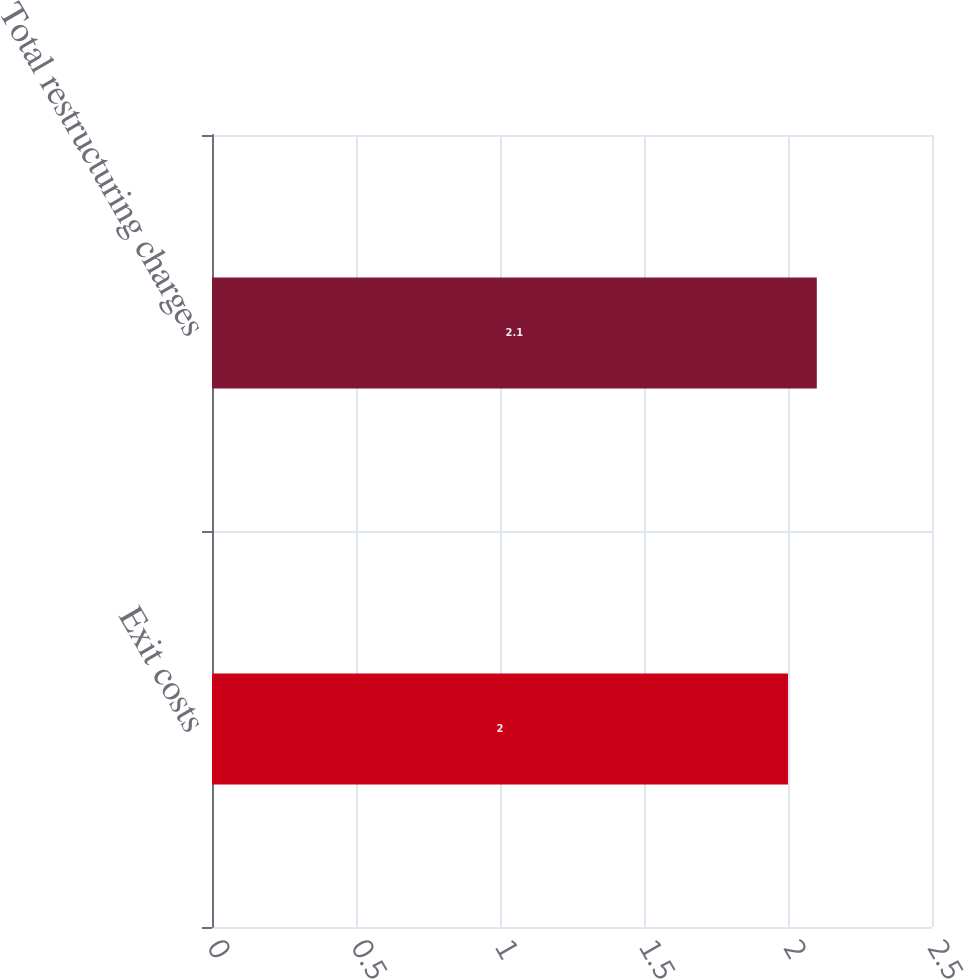Convert chart. <chart><loc_0><loc_0><loc_500><loc_500><bar_chart><fcel>Exit costs<fcel>Total restructuring charges<nl><fcel>2<fcel>2.1<nl></chart> 